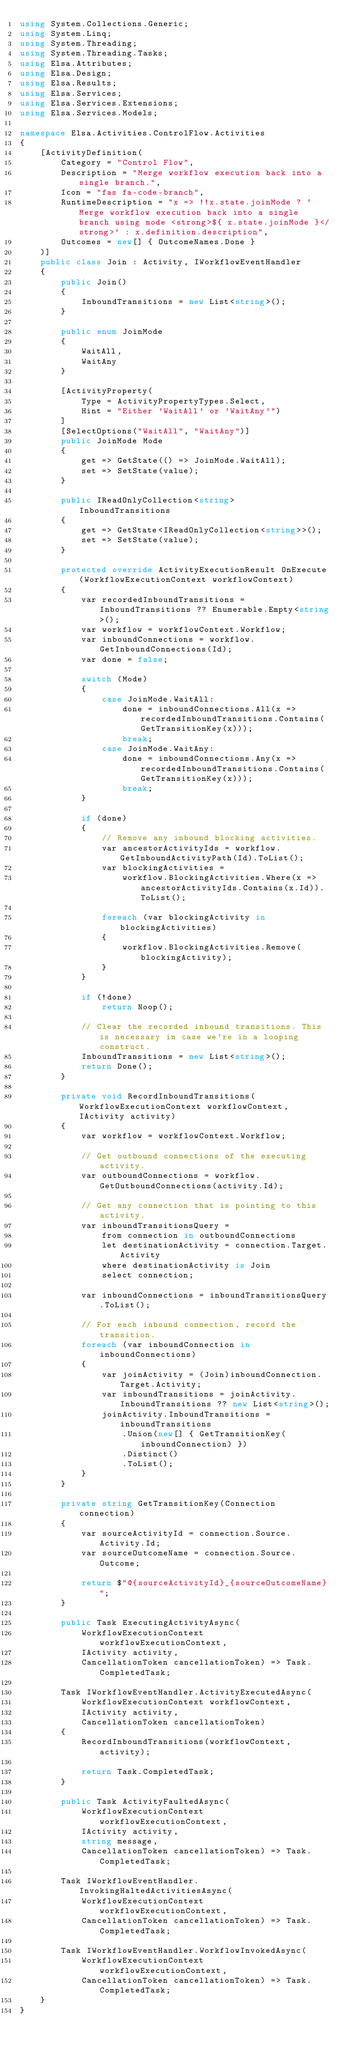Convert code to text. <code><loc_0><loc_0><loc_500><loc_500><_C#_>using System.Collections.Generic;
using System.Linq;
using System.Threading;
using System.Threading.Tasks;
using Elsa.Attributes;
using Elsa.Design;
using Elsa.Results;
using Elsa.Services;
using Elsa.Services.Extensions;
using Elsa.Services.Models;

namespace Elsa.Activities.ControlFlow.Activities
{
    [ActivityDefinition(
        Category = "Control Flow",
        Description = "Merge workflow execution back into a single branch.",
        Icon = "fas fa-code-branch",
        RuntimeDescription = "x => !!x.state.joinMode ? `Merge workflow execution back into a single branch using mode <strong>${ x.state.joinMode }</strong>` : x.definition.description",
        Outcomes = new[] { OutcomeNames.Done }
    )]
    public class Join : Activity, IWorkflowEventHandler
    {
        public Join()
        {
            InboundTransitions = new List<string>();
        }

        public enum JoinMode
        {
            WaitAll,
            WaitAny
        }

        [ActivityProperty(
            Type = ActivityPropertyTypes.Select,
            Hint = "Either 'WaitAll' or 'WaitAny'")
        ]
        [SelectOptions("WaitAll", "WaitAny")]
        public JoinMode Mode
        {
            get => GetState(() => JoinMode.WaitAll);
            set => SetState(value);
        }

        public IReadOnlyCollection<string> InboundTransitions
        {
            get => GetState<IReadOnlyCollection<string>>();
            set => SetState(value);
        }

        protected override ActivityExecutionResult OnExecute(WorkflowExecutionContext workflowContext)
        {
            var recordedInboundTransitions = InboundTransitions ?? Enumerable.Empty<string>();
            var workflow = workflowContext.Workflow;
            var inboundConnections = workflow.GetInboundConnections(Id);
            var done = false;

            switch (Mode)
            {
                case JoinMode.WaitAll:
                    done = inboundConnections.All(x => recordedInboundTransitions.Contains(GetTransitionKey(x)));
                    break;
                case JoinMode.WaitAny:
                    done = inboundConnections.Any(x => recordedInboundTransitions.Contains(GetTransitionKey(x)));
                    break;
            }

            if (done)
            {
                // Remove any inbound blocking activities.
                var ancestorActivityIds = workflow.GetInboundActivityPath(Id).ToList();
                var blockingActivities =
                    workflow.BlockingActivities.Where(x => ancestorActivityIds.Contains(x.Id)).ToList();

                foreach (var blockingActivity in blockingActivities)
                {
                    workflow.BlockingActivities.Remove(blockingActivity);
                }
            }

            if (!done)
                return Noop();
            
            // Clear the recorded inbound transitions. This is necessary in case we're in a looping construct. 
            InboundTransitions = new List<string>();
            return Done();
        }

        private void RecordInboundTransitions(WorkflowExecutionContext workflowContext, IActivity activity)
        {
            var workflow = workflowContext.Workflow;

            // Get outbound connections of the executing activity.
            var outboundConnections = workflow.GetOutboundConnections(activity.Id);

            // Get any connection that is pointing to this activity.
            var inboundTransitionsQuery =
                from connection in outboundConnections
                let destinationActivity = connection.Target.Activity
                where destinationActivity is Join
                select connection;

            var inboundConnections = inboundTransitionsQuery.ToList();

            // For each inbound connection, record the transition.
            foreach (var inboundConnection in inboundConnections)
            {
                var joinActivity = (Join)inboundConnection.Target.Activity;
                var inboundTransitions = joinActivity.InboundTransitions ?? new List<string>();
                joinActivity.InboundTransitions = inboundTransitions
                    .Union(new[] { GetTransitionKey(inboundConnection) })
                    .Distinct()
                    .ToList();
            }
        }

        private string GetTransitionKey(Connection connection)
        {
            var sourceActivityId = connection.Source.Activity.Id;
            var sourceOutcomeName = connection.Source.Outcome;

            return $"@{sourceActivityId}_{sourceOutcomeName}";
        }

        public Task ExecutingActivityAsync(
            WorkflowExecutionContext workflowExecutionContext,
            IActivity activity,
            CancellationToken cancellationToken) => Task.CompletedTask;

        Task IWorkflowEventHandler.ActivityExecutedAsync(
            WorkflowExecutionContext workflowContext,
            IActivity activity,
            CancellationToken cancellationToken)
        {
            RecordInboundTransitions(workflowContext, activity);

            return Task.CompletedTask;
        }

        public Task ActivityFaultedAsync(
            WorkflowExecutionContext workflowExecutionContext,
            IActivity activity,
            string message,
            CancellationToken cancellationToken) => Task.CompletedTask;

        Task IWorkflowEventHandler.InvokingHaltedActivitiesAsync(
            WorkflowExecutionContext workflowExecutionContext,
            CancellationToken cancellationToken) => Task.CompletedTask;

        Task IWorkflowEventHandler.WorkflowInvokedAsync(
            WorkflowExecutionContext workflowExecutionContext,
            CancellationToken cancellationToken) => Task.CompletedTask;
    }
}</code> 